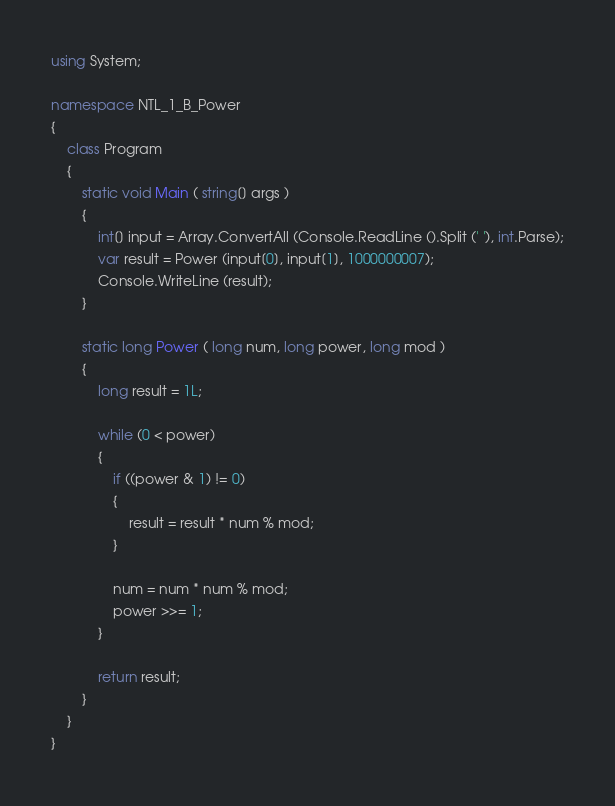Convert code to text. <code><loc_0><loc_0><loc_500><loc_500><_C#_>using System;

namespace NTL_1_B_Power
{
	class Program
	{
		static void Main ( string[] args )
		{
			int[] input = Array.ConvertAll (Console.ReadLine ().Split (' '), int.Parse);
			var result = Power (input[0], input[1], 1000000007);
			Console.WriteLine (result);
		}

		static long Power ( long num, long power, long mod )
		{
			long result = 1L;

			while (0 < power)
			{
				if ((power & 1) != 0)
				{
					result = result * num % mod;
				}

				num = num * num % mod;
				power >>= 1;
			}

			return result;
		}
	}
}

</code> 